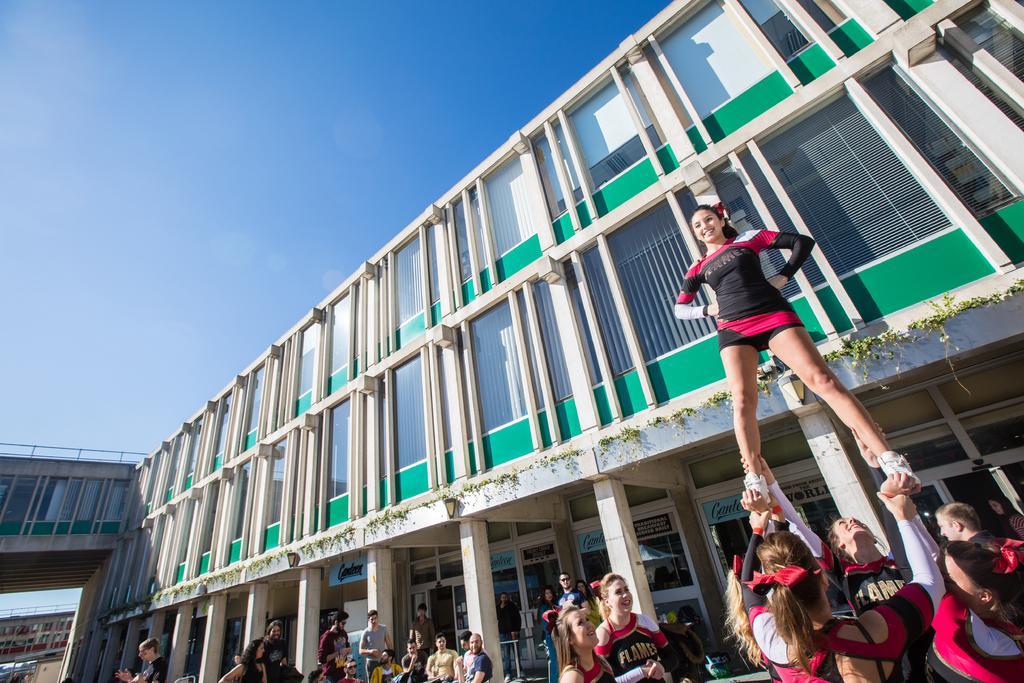Could you give a brief overview of what you see in this image? There are people standing and these women are holding legs. We can see building and pillars. In the background we can see building and sky. 